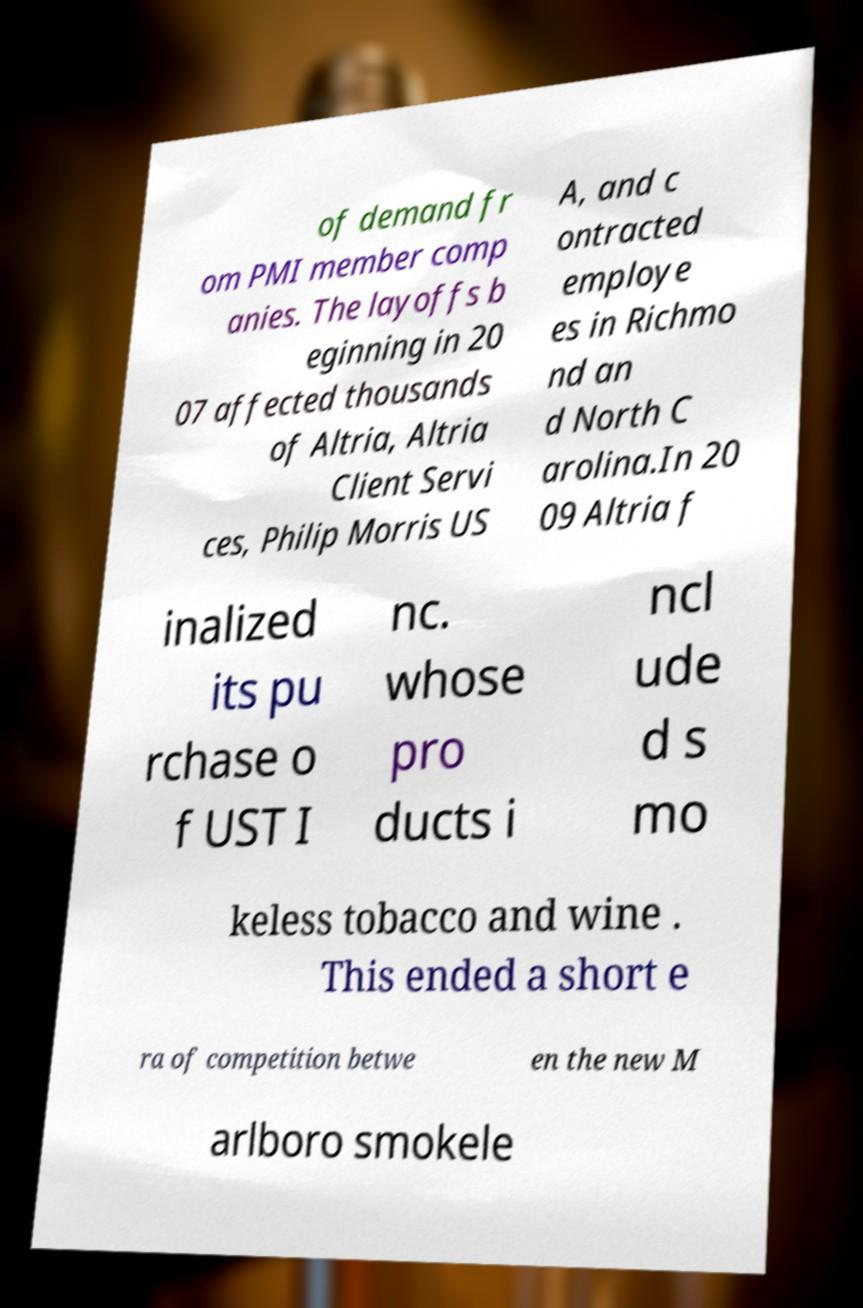Can you accurately transcribe the text from the provided image for me? of demand fr om PMI member comp anies. The layoffs b eginning in 20 07 affected thousands of Altria, Altria Client Servi ces, Philip Morris US A, and c ontracted employe es in Richmo nd an d North C arolina.In 20 09 Altria f inalized its pu rchase o f UST I nc. whose pro ducts i ncl ude d s mo keless tobacco and wine . This ended a short e ra of competition betwe en the new M arlboro smokele 